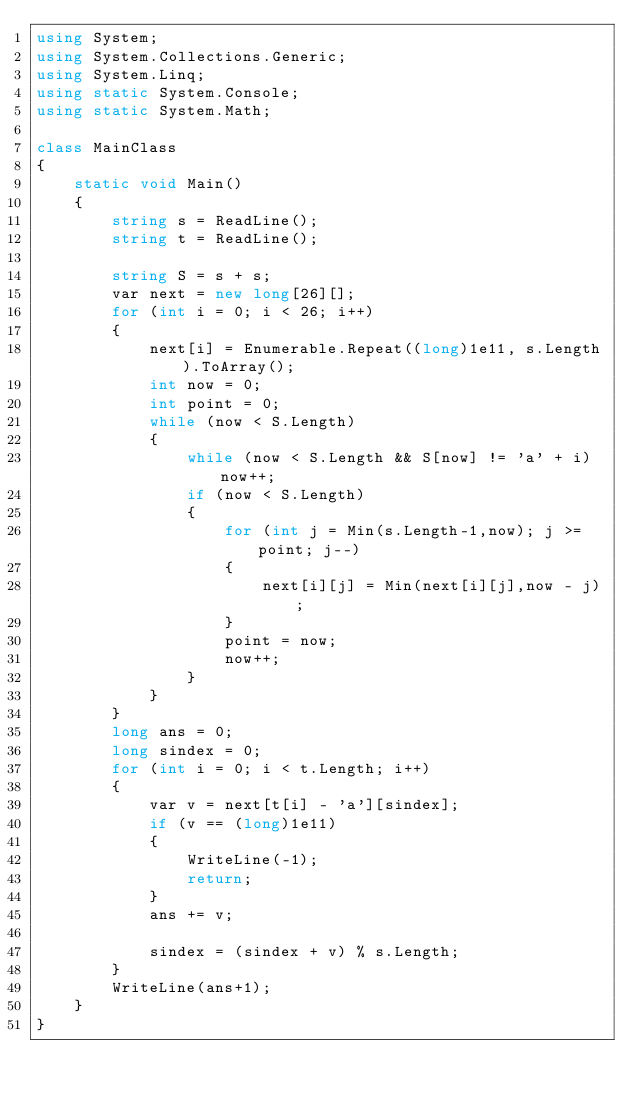<code> <loc_0><loc_0><loc_500><loc_500><_C#_>using System;
using System.Collections.Generic;
using System.Linq;
using static System.Console;
using static System.Math;

class MainClass
{
    static void Main()
    {
        string s = ReadLine();
        string t = ReadLine();

        string S = s + s;
        var next = new long[26][];
        for (int i = 0; i < 26; i++)
        {
            next[i] = Enumerable.Repeat((long)1e11, s.Length).ToArray();
            int now = 0;
            int point = 0;
            while (now < S.Length)
            {
                while (now < S.Length && S[now] != 'a' + i) now++;
                if (now < S.Length)
                {
                    for (int j = Min(s.Length-1,now); j >=point; j--)
                    {
                        next[i][j] = Min(next[i][j],now - j);
                    }
                    point = now;
                    now++;
                }
            }
        }
        long ans = 0;
        long sindex = 0;
        for (int i = 0; i < t.Length; i++)
        {
            var v = next[t[i] - 'a'][sindex];
            if (v == (long)1e11)
            {
                WriteLine(-1);
                return;
            }
            ans += v;

            sindex = (sindex + v) % s.Length;
        }
        WriteLine(ans+1);
    }
}
</code> 